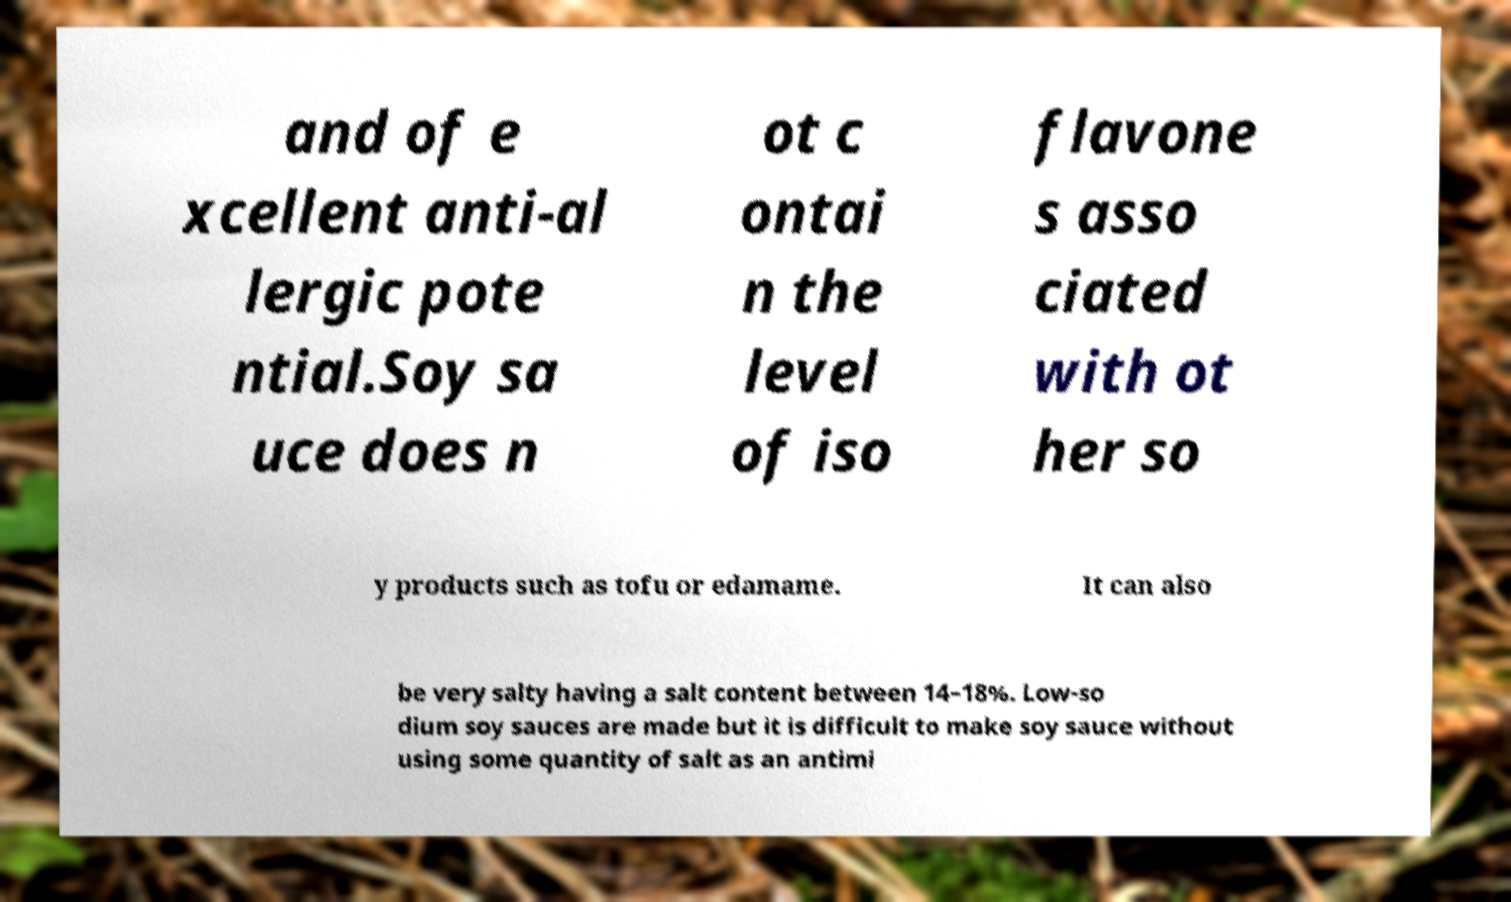I need the written content from this picture converted into text. Can you do that? and of e xcellent anti-al lergic pote ntial.Soy sa uce does n ot c ontai n the level of iso flavone s asso ciated with ot her so y products such as tofu or edamame. It can also be very salty having a salt content between 14–18%. Low-so dium soy sauces are made but it is difficult to make soy sauce without using some quantity of salt as an antimi 